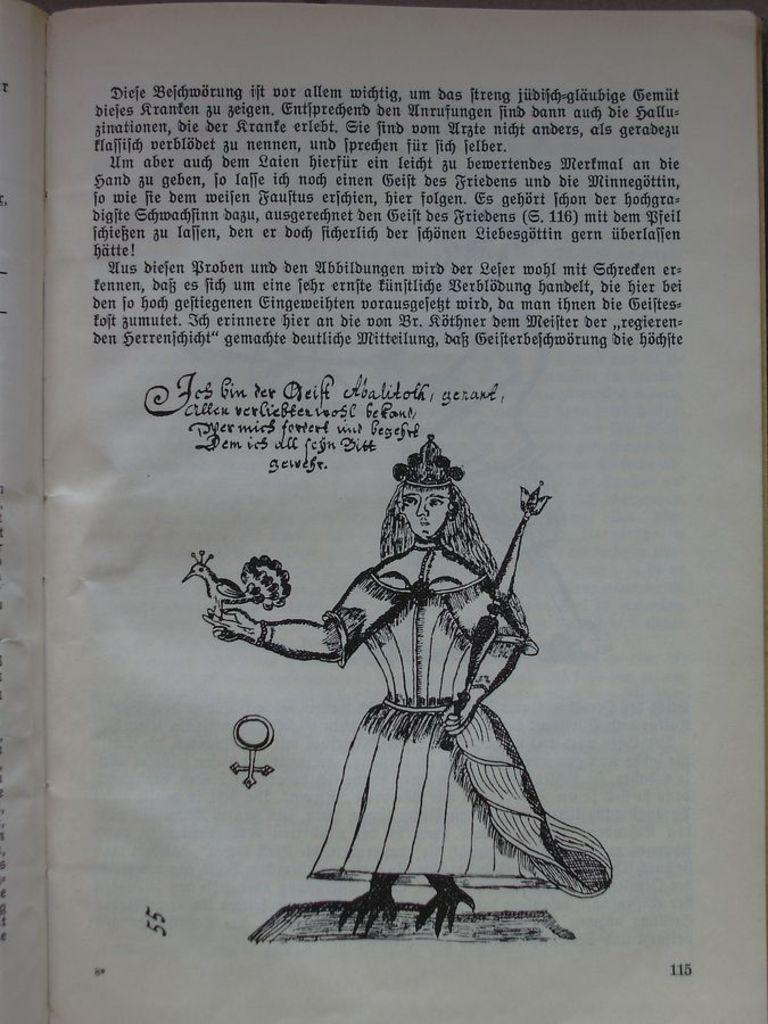What is depicted in the print in the image? There is a print of a man holding a bird in the image. What is written or displayed above the man and bird in the image? There is text above the man and bird in the image. What material is the print on? The print is on a paper. Reasoning: Let' Let's think step by step in order to produce the conversation. We start by identifying the main subject of the image, which is the print of a man holding a bird. Then, we describe the text that is present above the man and bird, as well as the material the print is on, which is paper. Each question is designed to elicit a specific detail about the image that is known from the provided facts. Absurd Question/Answer: What type of nerve can be seen in the image? There is no nerve present in the image; it features a print of a man holding a bird with text above them on a paper. What type of cable can be seen connecting the man and bird in the image? There is no cable present in the image; it features a print of a man holding a bird with text above them on a paper. 